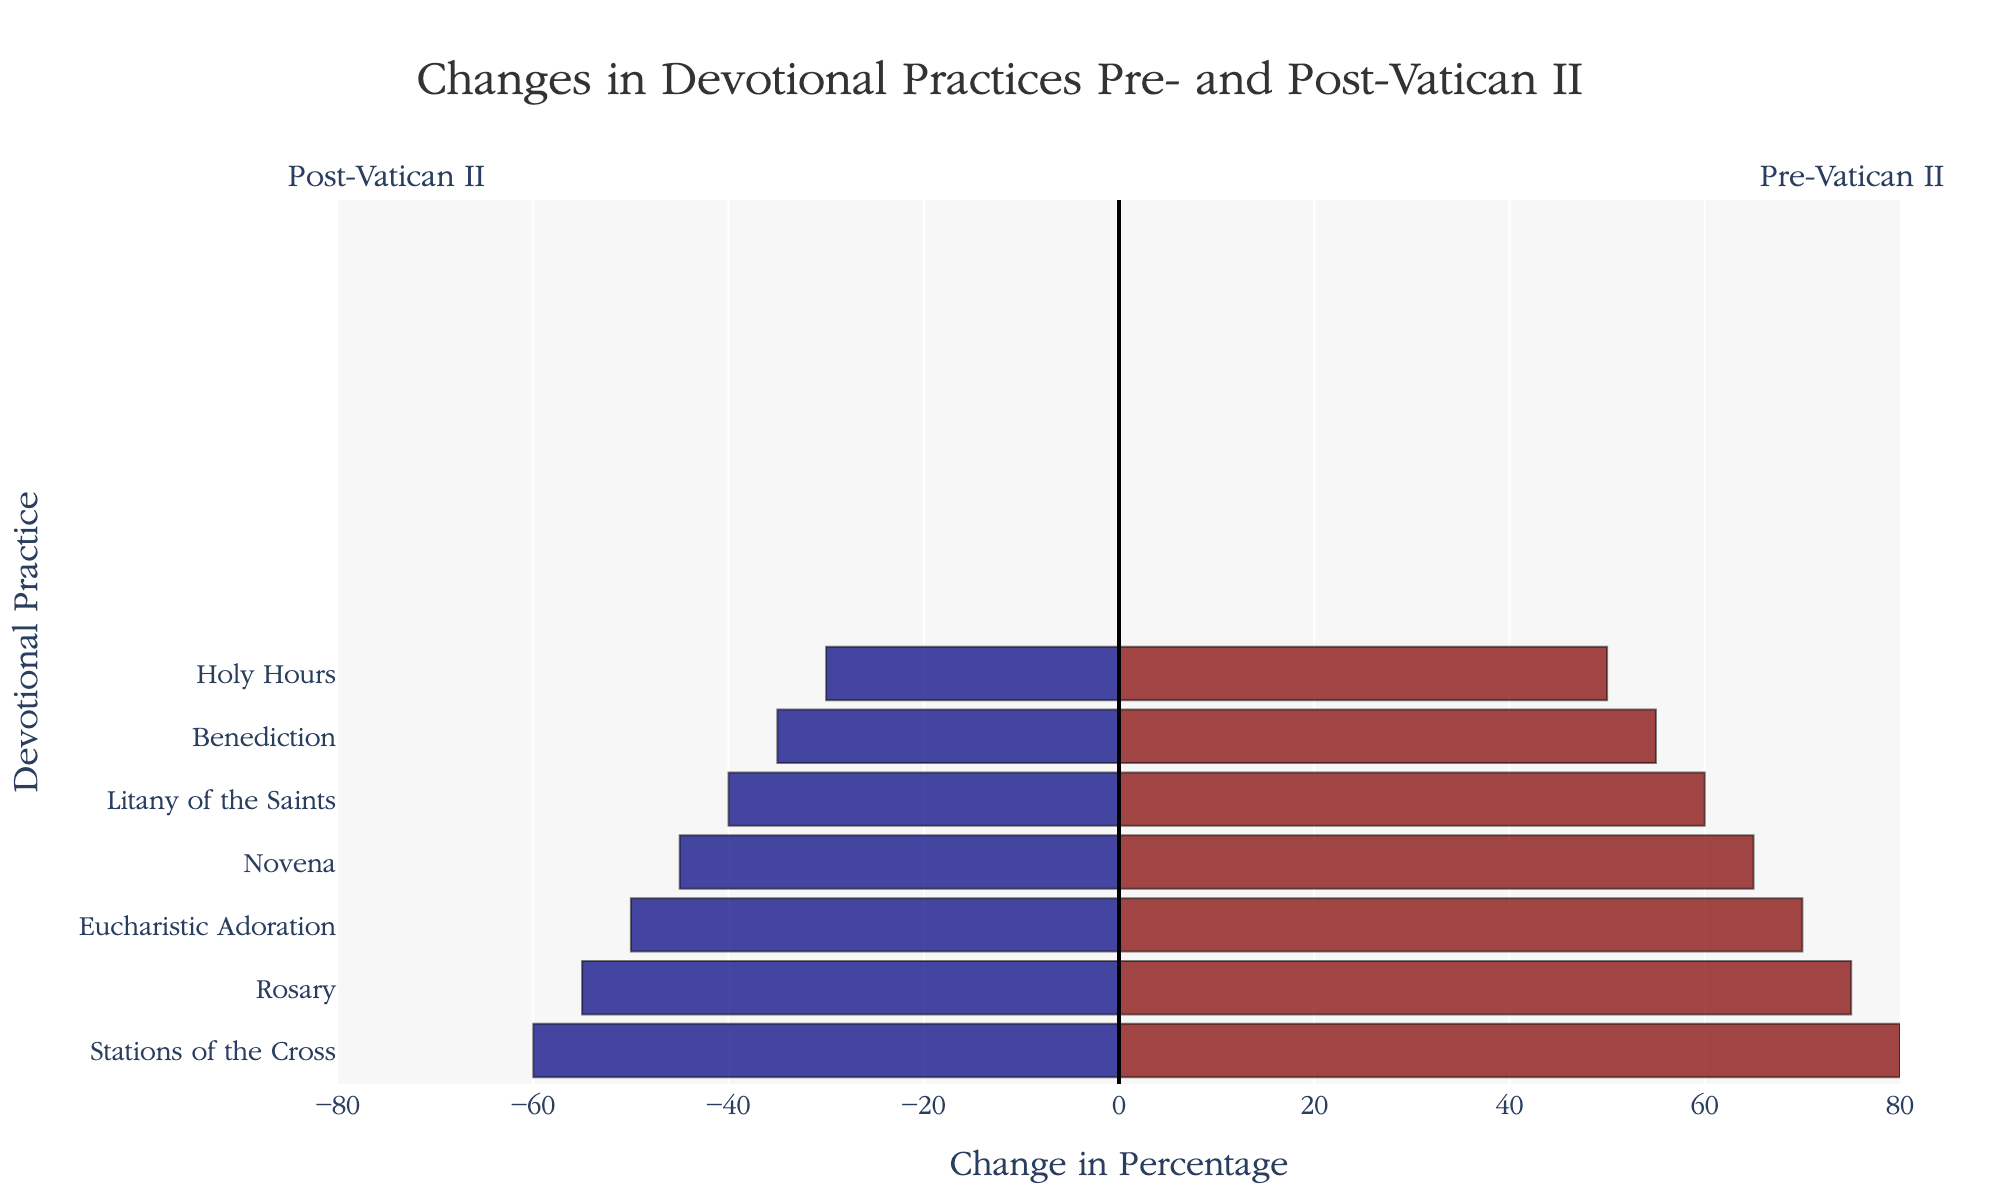What's the largest decline observed in devotional practices from Pre-Vatican II to Post-Vatican II? First, identify the maximum difference between Pre-Vatican II and Post-Vatican II percentages. "Holy Hours" declined from 50 to 30, a difference of 20%. However, "Stations of the Cross" declined from 80 to 60, which is also 20%. So the answer is tied between these two practices.
Answer: 20% Which practice experienced the smallest change from Pre-Vatican II to Post-Vatican II? Identify the smallest difference between the Pre-Vatican II and Post-Vatican II percentages. "Rosary" decreased from 75 to 55, a difference of 20%, which is the smallest among all practices listed.
Answer: Rosary Compare the change in percentage for "Rosary" and "Stations of the Cross" from Pre-Vatican II to Post-Vatican II. Which decreased more? Calculate the difference for both: Rosary (75 - 55 = 20), Stations of the Cross (80 - 60 = 20). Both have the same decrease.
Answer: Both decreased equally What is the general trend observed in all devotional practices from Pre-Vatican II to Post-Vatican II? All practices show a decrease in percentage from Pre-Vatican II to Post-Vatican II. The trend indicates a general decline in these devotional practices.
Answer: Decrease How much lower is the Post-Vatican II percentage for "Eucharistic Adoration" compared to "Novena"? Post-Vatican II percentage for "Eucharistic Adoration" is 50, and for "Novena" it is 45. The difference is 50 - 45 = 5.
Answer: 5% What is the sum of the percentages for all Pre-Vatican II devotional practices? Add percentages for all Pre-Vatican II practices: 75 (Rosary) + 60 (Litany) + 70 (Eucharistic Adoration) + 65 (Novena) + 55 (Benediction) + 80 (Stations of the Cross) + 50 (Holy Hours) = 455.
Answer: 455 Which practice shows the steepest decline in terms of visual length on the plot? Visually, all declines can be compared by the bar lengths extending to the left. The practice with the longest bar to the left is "Holy Hours" and "Stations of the Cross", showing a steep decline. The length of the bar visually represents the 20% decline.
Answer: Holy Hours and Stations of the Cross Among "Benediction" and "Litany of the Saints", which practice had a higher percentage Pre-Vatican II? Pre-Vatican II percentage for "Benediction" is 55, and for "Litany of the Saints," it is 60. 60 is higher than 55.
Answer: Litany of the Saints Calculate the average percentage change for all practices from Pre-Vatican II to Post-Vatican II. Find the percentage change for each practice and then average them. Calculate the change for each: Rosary (20%), Litany of the Saints (20%), Eucharistic Adoration (20%), Novena (20%), Benediction (20%), Stations of the Cross (20%), Holy Hours (20%). Average = (20 + 20 + 20 + 20 + 20 + 20 + 20)/7 = 20%.
Answer: 20% Which practices have the exact same percentage change? Calculate the change for each practice and compare: Rosary (20), Litany of the Saints (20), Eucharistic Adoration (20), Novena (20), Benediction (20), Stations of the Cross (20), Holy Hours (20). All have the same percentage change.
Answer: All practices 